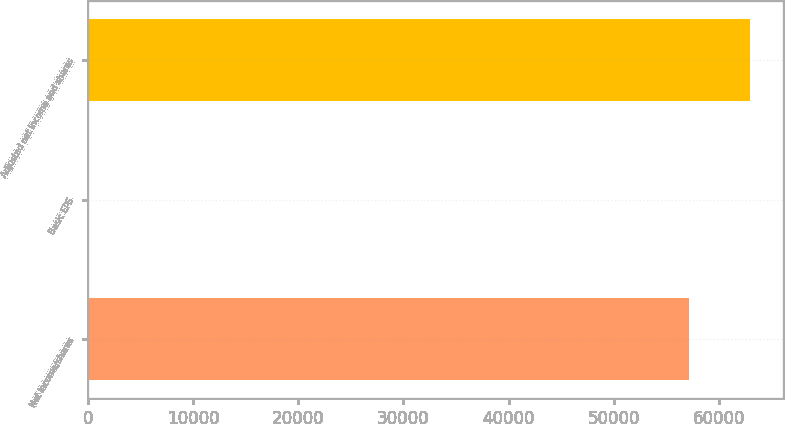Convert chart to OTSL. <chart><loc_0><loc_0><loc_500><loc_500><bar_chart><fcel>Net income/shares<fcel>Basic EPS<fcel>Adjusted net income and shares<nl><fcel>57196<fcel>0.31<fcel>62972.3<nl></chart> 